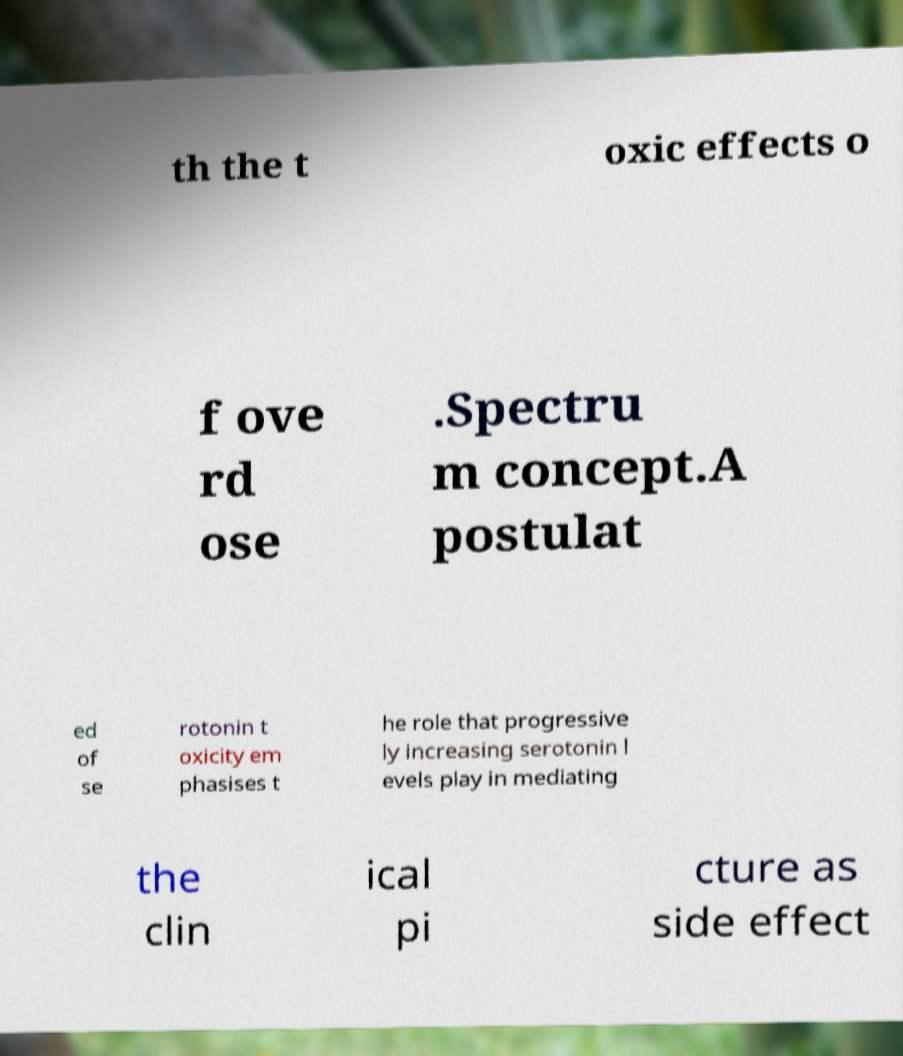Please identify and transcribe the text found in this image. th the t oxic effects o f ove rd ose .Spectru m concept.A postulat ed of se rotonin t oxicity em phasises t he role that progressive ly increasing serotonin l evels play in mediating the clin ical pi cture as side effect 